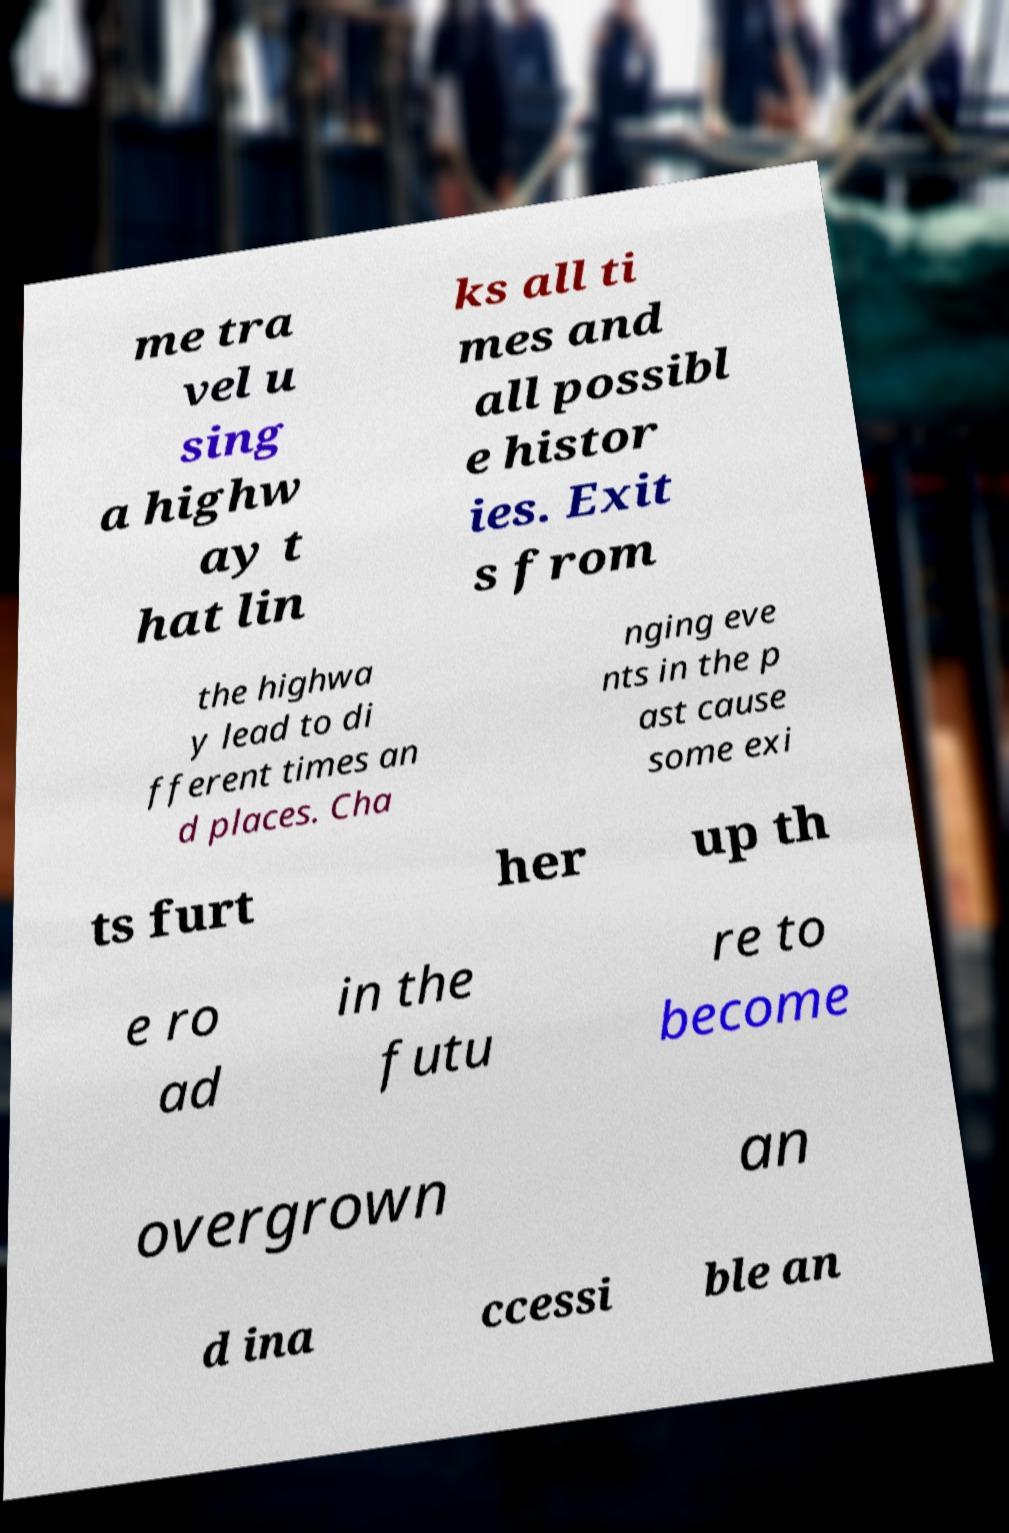Please read and relay the text visible in this image. What does it say? me tra vel u sing a highw ay t hat lin ks all ti mes and all possibl e histor ies. Exit s from the highwa y lead to di fferent times an d places. Cha nging eve nts in the p ast cause some exi ts furt her up th e ro ad in the futu re to become overgrown an d ina ccessi ble an 